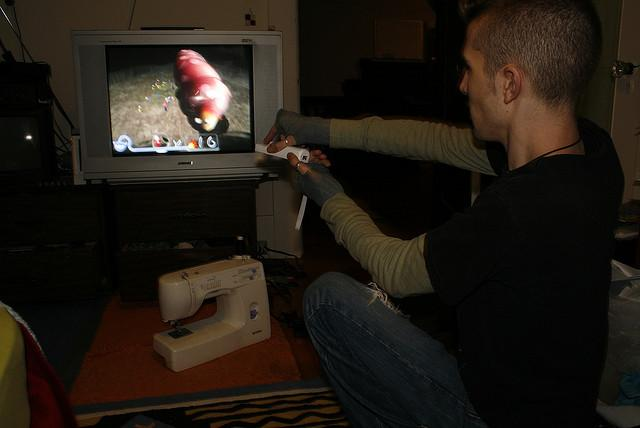The item on the floor looks like what? sewing machine 